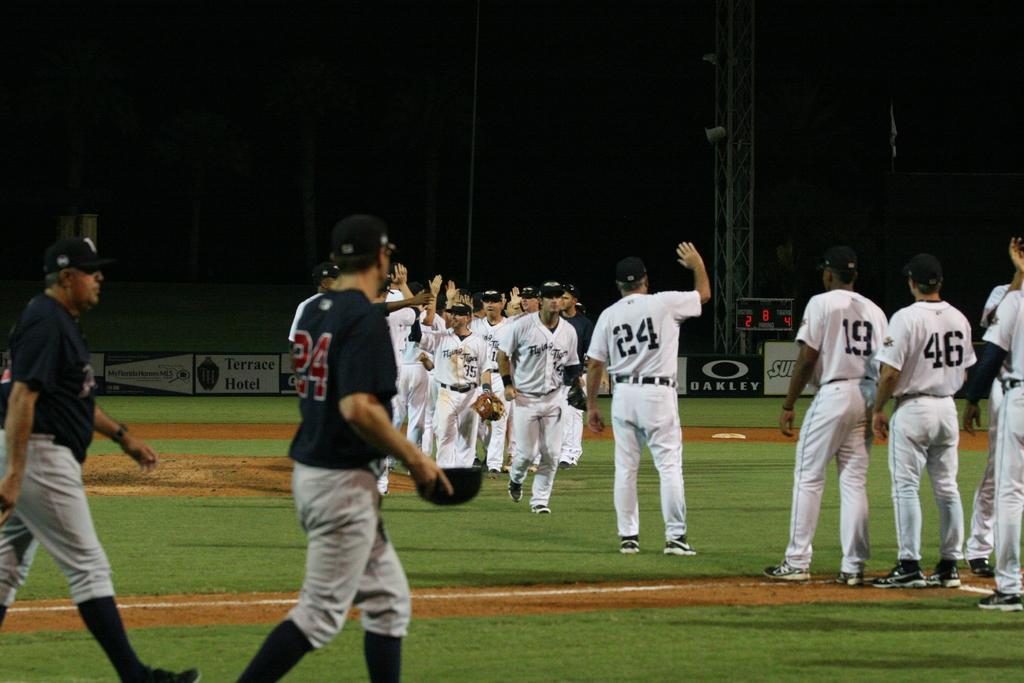Could you give a brief overview of what you see in this image? On the left there are two persons walking on the ground and on the right there are few persons walking and few are standing on the ground. In the background there are hoardings,poles,flag and other objects. 